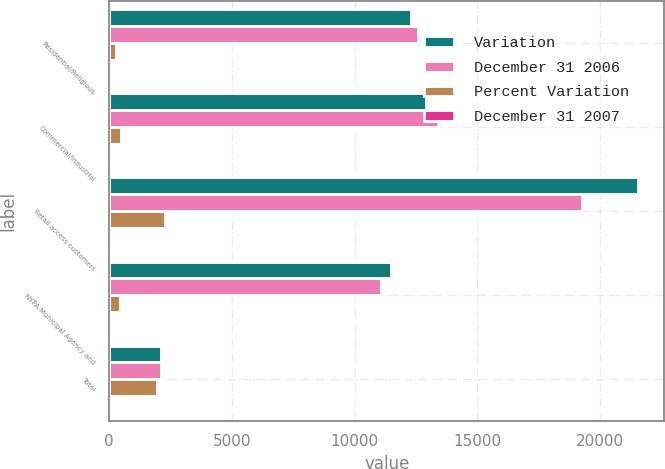Convert chart. <chart><loc_0><loc_0><loc_500><loc_500><stacked_bar_chart><ecel><fcel>Residential/Religious<fcel>Commercial/Industrial<fcel>Retail access customers<fcel>NYPA Municipal Agency and<fcel>Total<nl><fcel>Variation<fcel>12312<fcel>12918<fcel>21532<fcel>11499<fcel>2114.5<nl><fcel>December 31 2006<fcel>12590<fcel>13409<fcel>19256<fcel>11053<fcel>2114.5<nl><fcel>Percent Variation<fcel>278<fcel>491<fcel>2276<fcel>446<fcel>1953<nl><fcel>December 31 2007<fcel>2.2<fcel>3.7<fcel>11.8<fcel>4<fcel>3.5<nl></chart> 